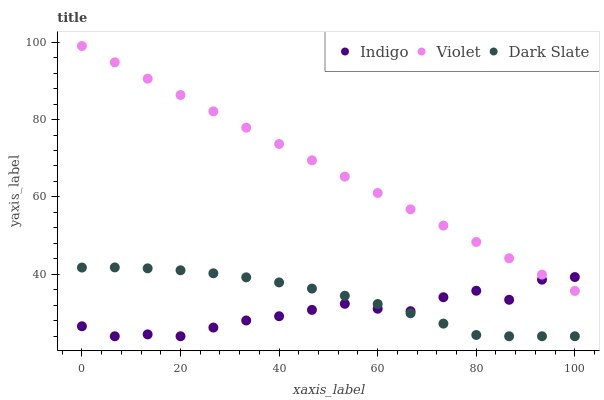Does Indigo have the minimum area under the curve?
Answer yes or no. Yes. Does Violet have the maximum area under the curve?
Answer yes or no. Yes. Does Violet have the minimum area under the curve?
Answer yes or no. No. Does Indigo have the maximum area under the curve?
Answer yes or no. No. Is Violet the smoothest?
Answer yes or no. Yes. Is Indigo the roughest?
Answer yes or no. Yes. Is Indigo the smoothest?
Answer yes or no. No. Is Violet the roughest?
Answer yes or no. No. Does Dark Slate have the lowest value?
Answer yes or no. Yes. Does Violet have the lowest value?
Answer yes or no. No. Does Violet have the highest value?
Answer yes or no. Yes. Does Indigo have the highest value?
Answer yes or no. No. Is Dark Slate less than Violet?
Answer yes or no. Yes. Is Violet greater than Dark Slate?
Answer yes or no. Yes. Does Indigo intersect Dark Slate?
Answer yes or no. Yes. Is Indigo less than Dark Slate?
Answer yes or no. No. Is Indigo greater than Dark Slate?
Answer yes or no. No. Does Dark Slate intersect Violet?
Answer yes or no. No. 